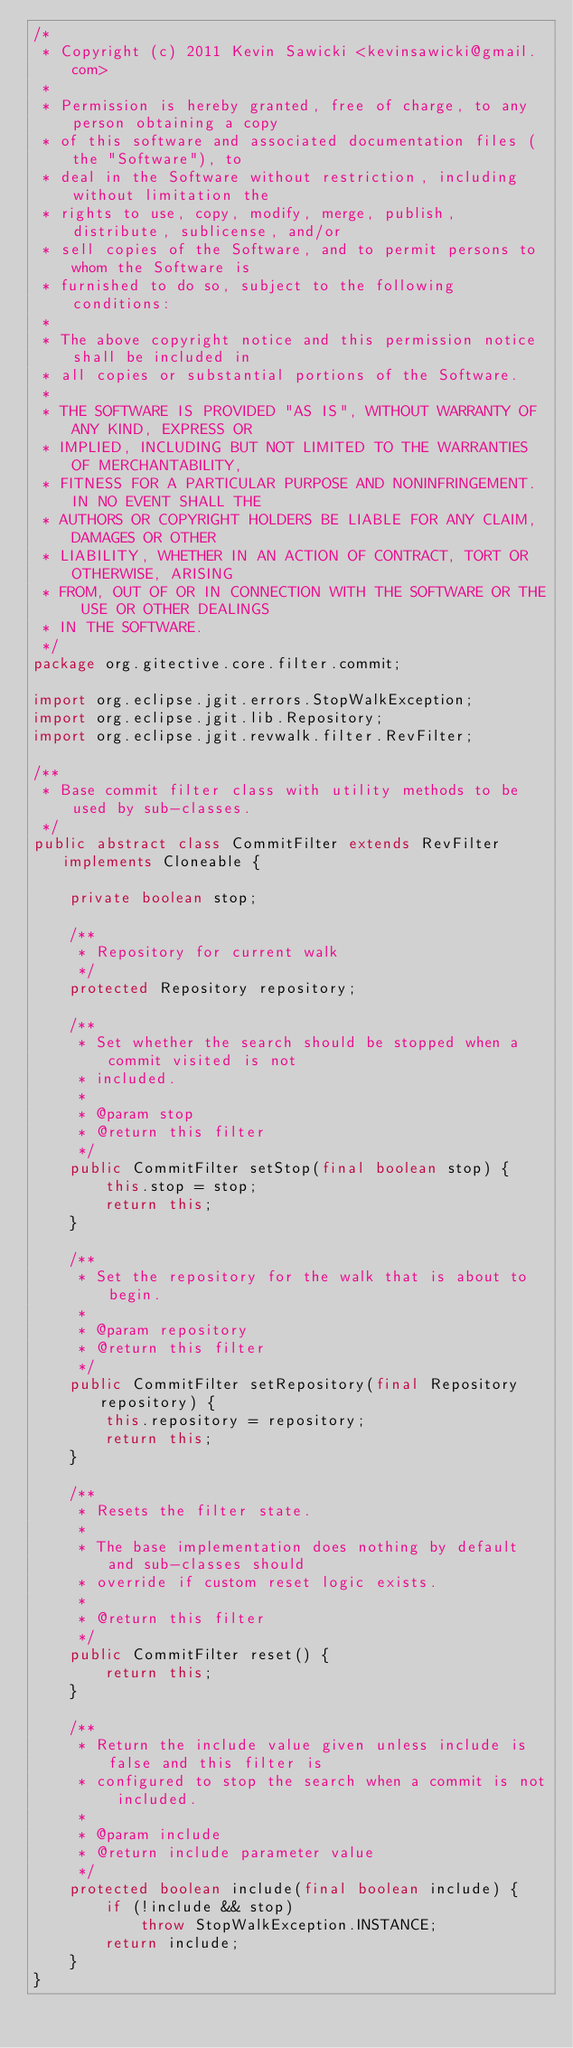<code> <loc_0><loc_0><loc_500><loc_500><_Java_>/*
 * Copyright (c) 2011 Kevin Sawicki <kevinsawicki@gmail.com>
 *
 * Permission is hereby granted, free of charge, to any person obtaining a copy
 * of this software and associated documentation files (the "Software"), to
 * deal in the Software without restriction, including without limitation the
 * rights to use, copy, modify, merge, publish, distribute, sublicense, and/or
 * sell copies of the Software, and to permit persons to whom the Software is
 * furnished to do so, subject to the following conditions:
 *
 * The above copyright notice and this permission notice shall be included in
 * all copies or substantial portions of the Software.
 *
 * THE SOFTWARE IS PROVIDED "AS IS", WITHOUT WARRANTY OF ANY KIND, EXPRESS OR
 * IMPLIED, INCLUDING BUT NOT LIMITED TO THE WARRANTIES OF MERCHANTABILITY,
 * FITNESS FOR A PARTICULAR PURPOSE AND NONINFRINGEMENT. IN NO EVENT SHALL THE
 * AUTHORS OR COPYRIGHT HOLDERS BE LIABLE FOR ANY CLAIM, DAMAGES OR OTHER
 * LIABILITY, WHETHER IN AN ACTION OF CONTRACT, TORT OR OTHERWISE, ARISING
 * FROM, OUT OF OR IN CONNECTION WITH THE SOFTWARE OR THE USE OR OTHER DEALINGS
 * IN THE SOFTWARE.
 */
package org.gitective.core.filter.commit;

import org.eclipse.jgit.errors.StopWalkException;
import org.eclipse.jgit.lib.Repository;
import org.eclipse.jgit.revwalk.filter.RevFilter;

/**
 * Base commit filter class with utility methods to be used by sub-classes.
 */
public abstract class CommitFilter extends RevFilter implements Cloneable {

	private boolean stop;

	/**
	 * Repository for current walk
	 */
	protected Repository repository;

	/**
	 * Set whether the search should be stopped when a commit visited is not
	 * included.
	 * 
	 * @param stop
	 * @return this filter
	 */
	public CommitFilter setStop(final boolean stop) {
		this.stop = stop;
		return this;
	}

	/**
	 * Set the repository for the walk that is about to begin.
	 * 
	 * @param repository
	 * @return this filter
	 */
	public CommitFilter setRepository(final Repository repository) {
		this.repository = repository;
		return this;
	}

	/**
	 * Resets the filter state.
	 * 
	 * The base implementation does nothing by default and sub-classes should
	 * override if custom reset logic exists.
	 * 
	 * @return this filter
	 */
	public CommitFilter reset() {
		return this;
	}

	/**
	 * Return the include value given unless include is false and this filter is
	 * configured to stop the search when a commit is not included.
	 * 
	 * @param include
	 * @return include parameter value
	 */
	protected boolean include(final boolean include) {
		if (!include && stop)
			throw StopWalkException.INSTANCE;
		return include;
	}
}
</code> 